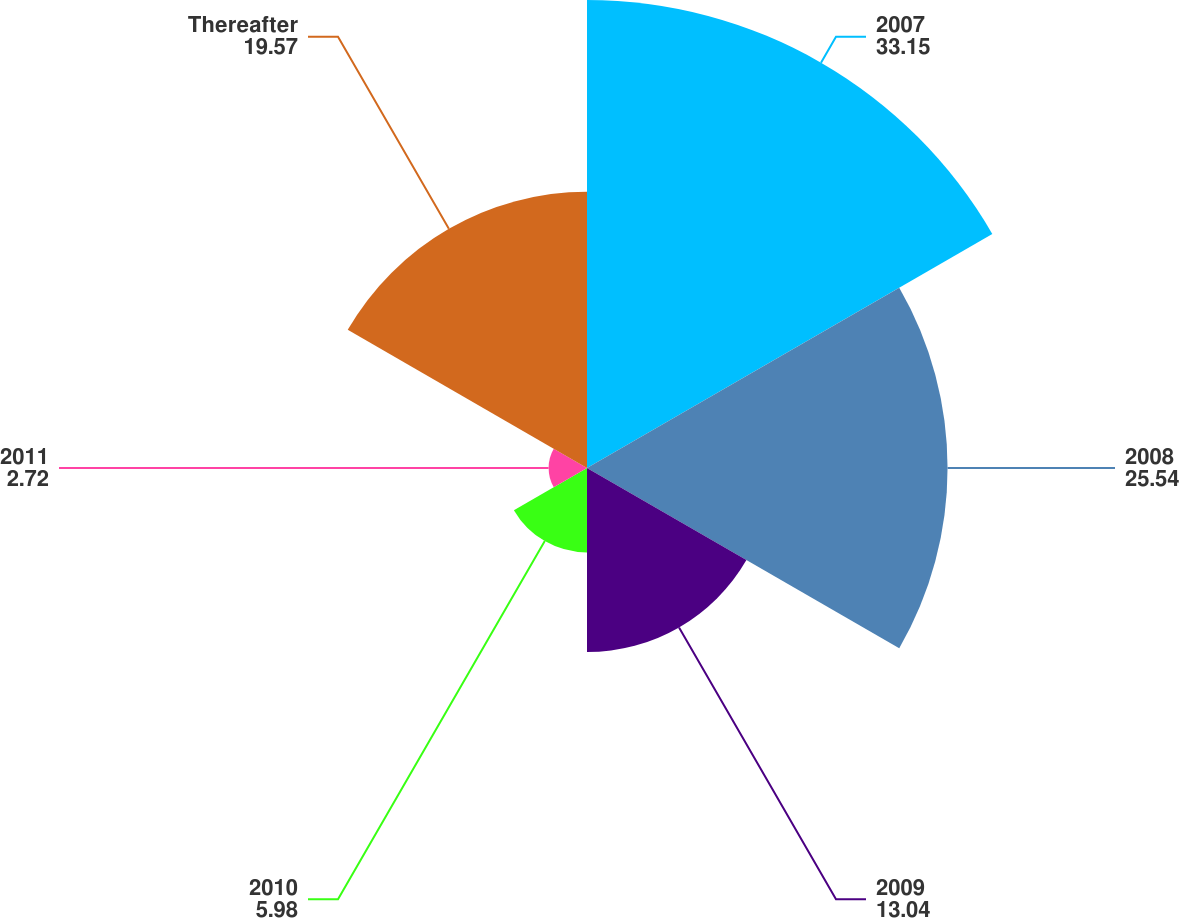Convert chart. <chart><loc_0><loc_0><loc_500><loc_500><pie_chart><fcel>2007<fcel>2008<fcel>2009<fcel>2010<fcel>2011<fcel>Thereafter<nl><fcel>33.15%<fcel>25.54%<fcel>13.04%<fcel>5.98%<fcel>2.72%<fcel>19.57%<nl></chart> 